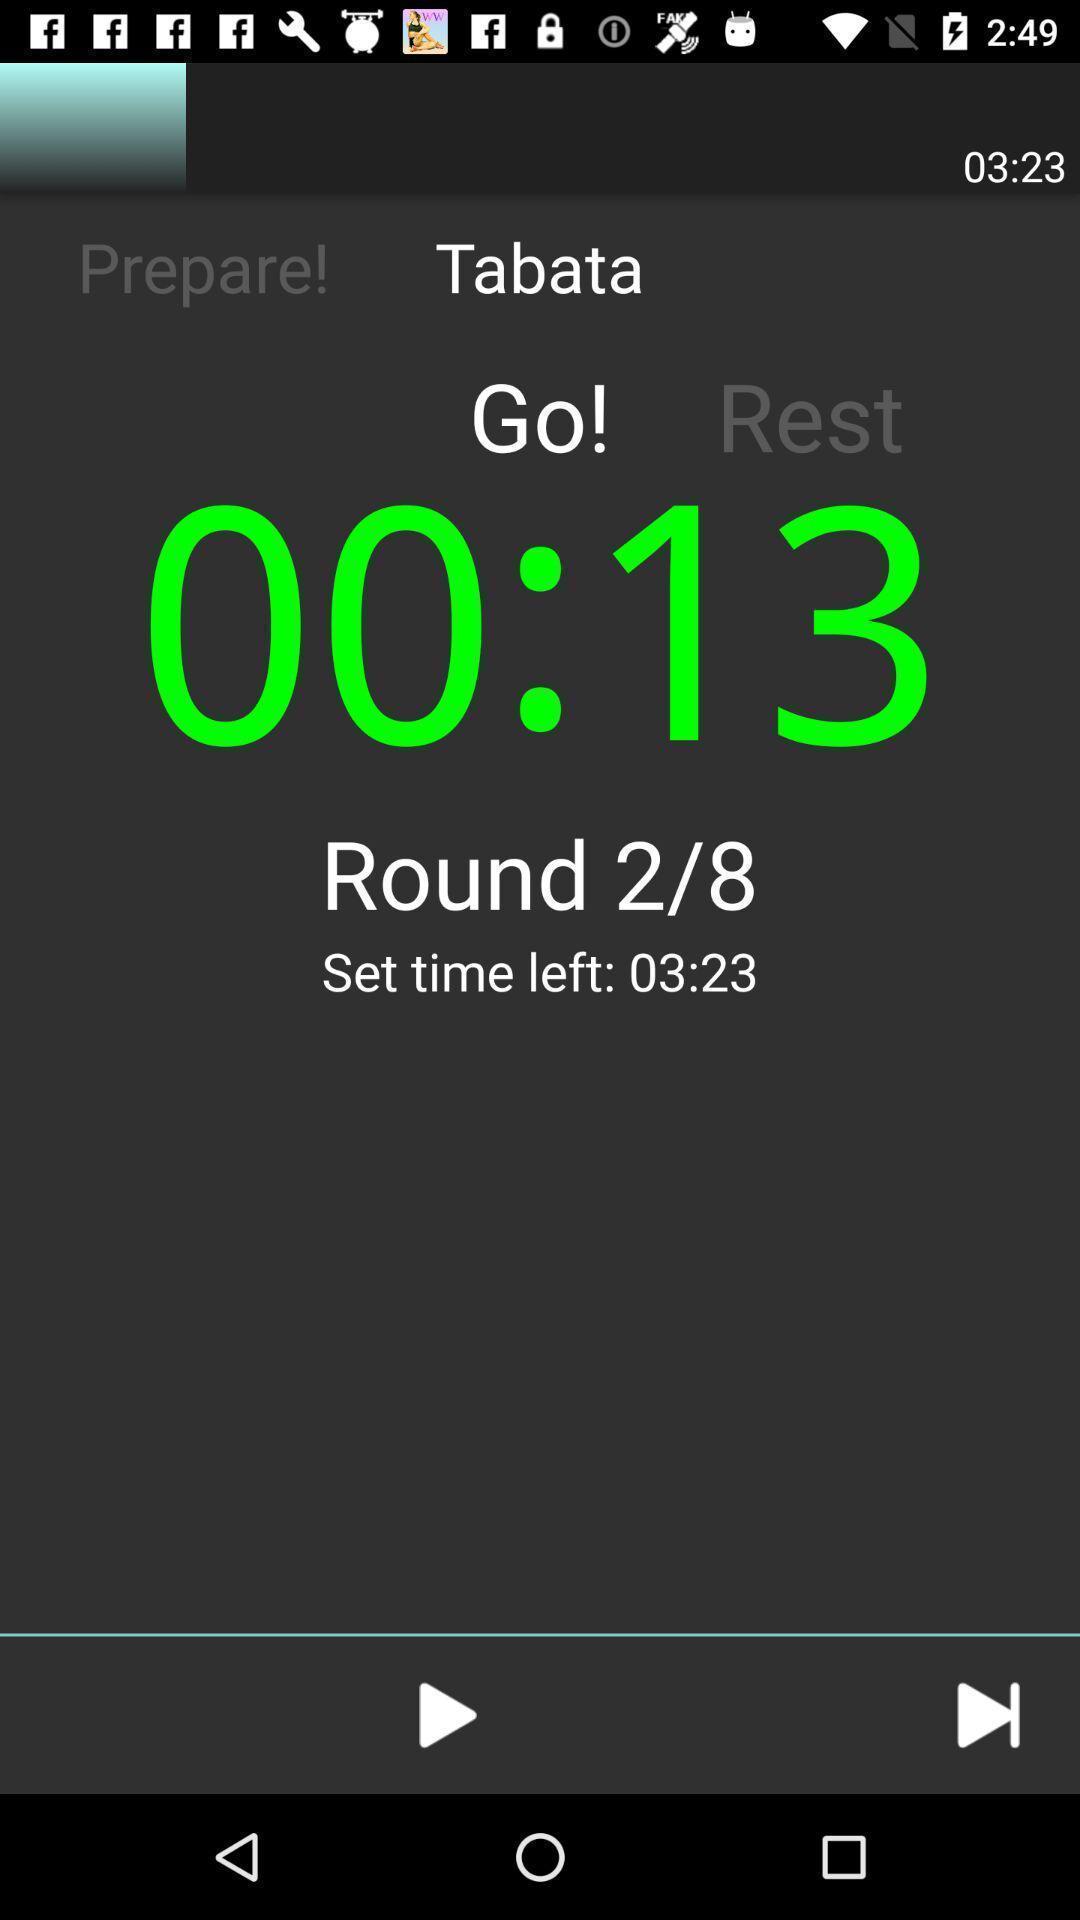Describe this image in words. Screen page displaying a timer with multiple options. 